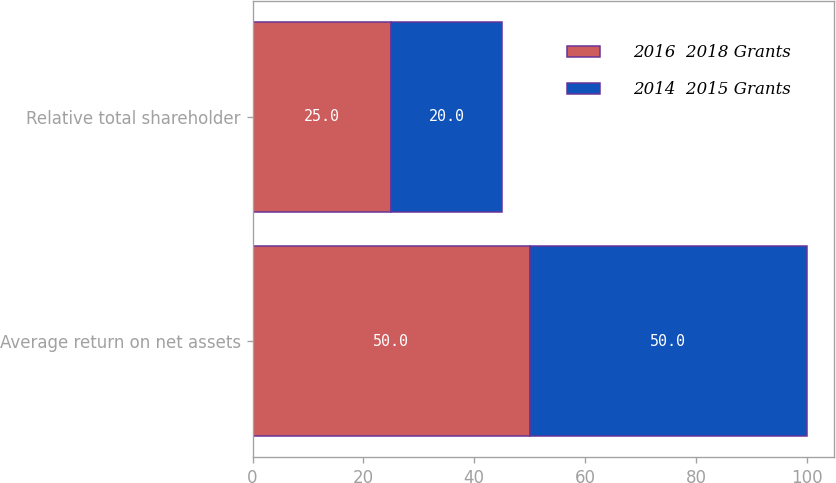Convert chart. <chart><loc_0><loc_0><loc_500><loc_500><stacked_bar_chart><ecel><fcel>Average return on net assets<fcel>Relative total shareholder<nl><fcel>2016  2018 Grants<fcel>50<fcel>25<nl><fcel>2014  2015 Grants<fcel>50<fcel>20<nl></chart> 